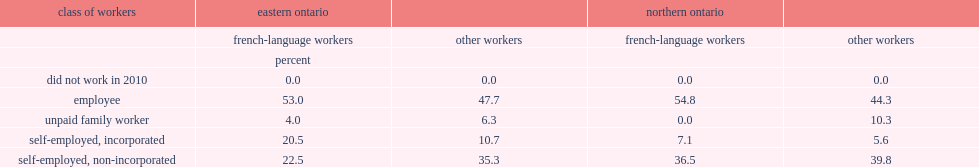In eastern ontario, which group of workers has a higher proportion of workers who were employees? french-language agricultural workers or other agricultural workers? French-language workers. 